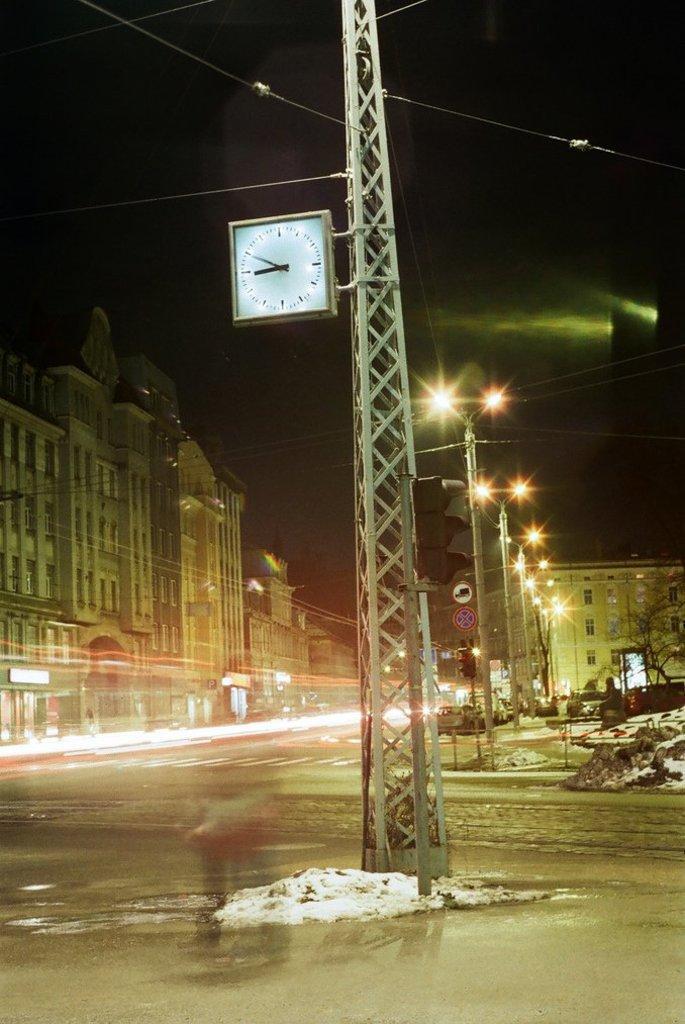How would you summarize this image in a sentence or two? In this picture there is a metal tower with square clock placed on it. Behind there is a street with some lights pole. On the left side there are some building. 